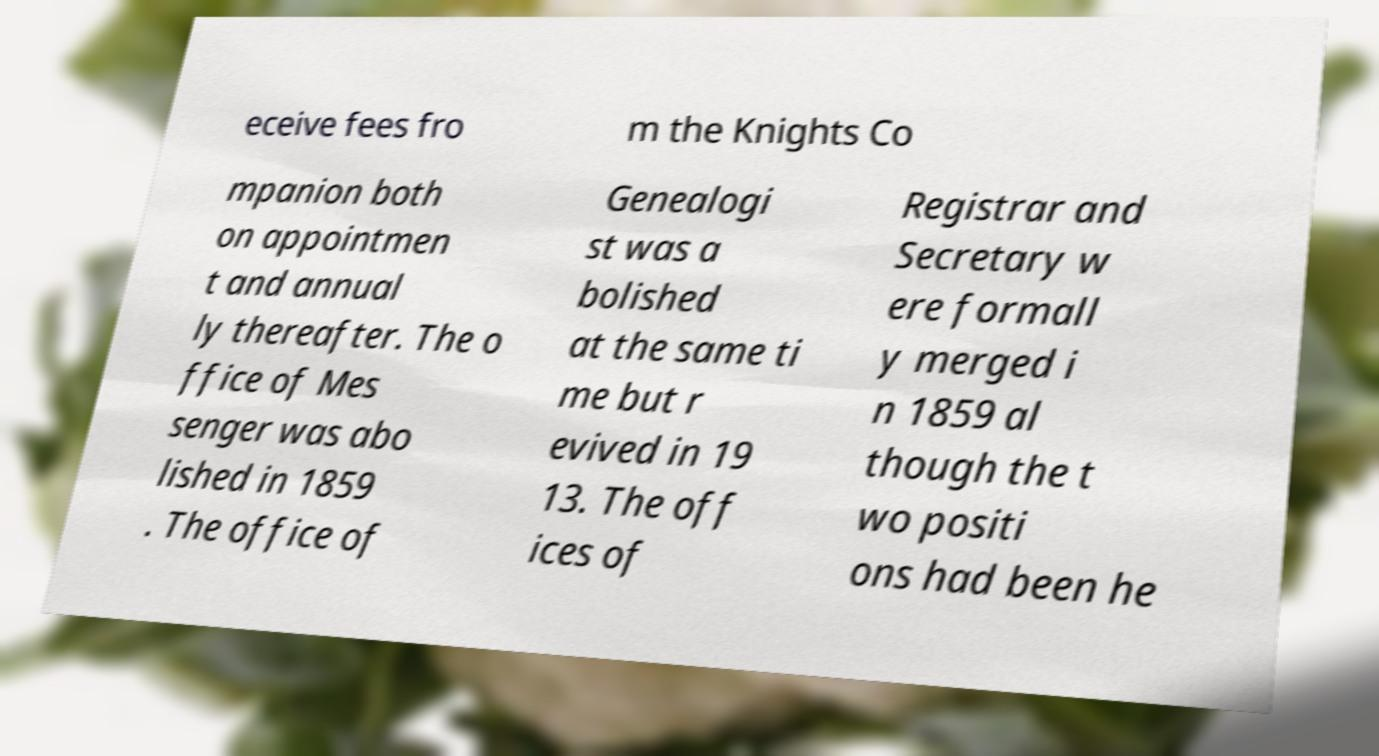Please identify and transcribe the text found in this image. eceive fees fro m the Knights Co mpanion both on appointmen t and annual ly thereafter. The o ffice of Mes senger was abo lished in 1859 . The office of Genealogi st was a bolished at the same ti me but r evived in 19 13. The off ices of Registrar and Secretary w ere formall y merged i n 1859 al though the t wo positi ons had been he 